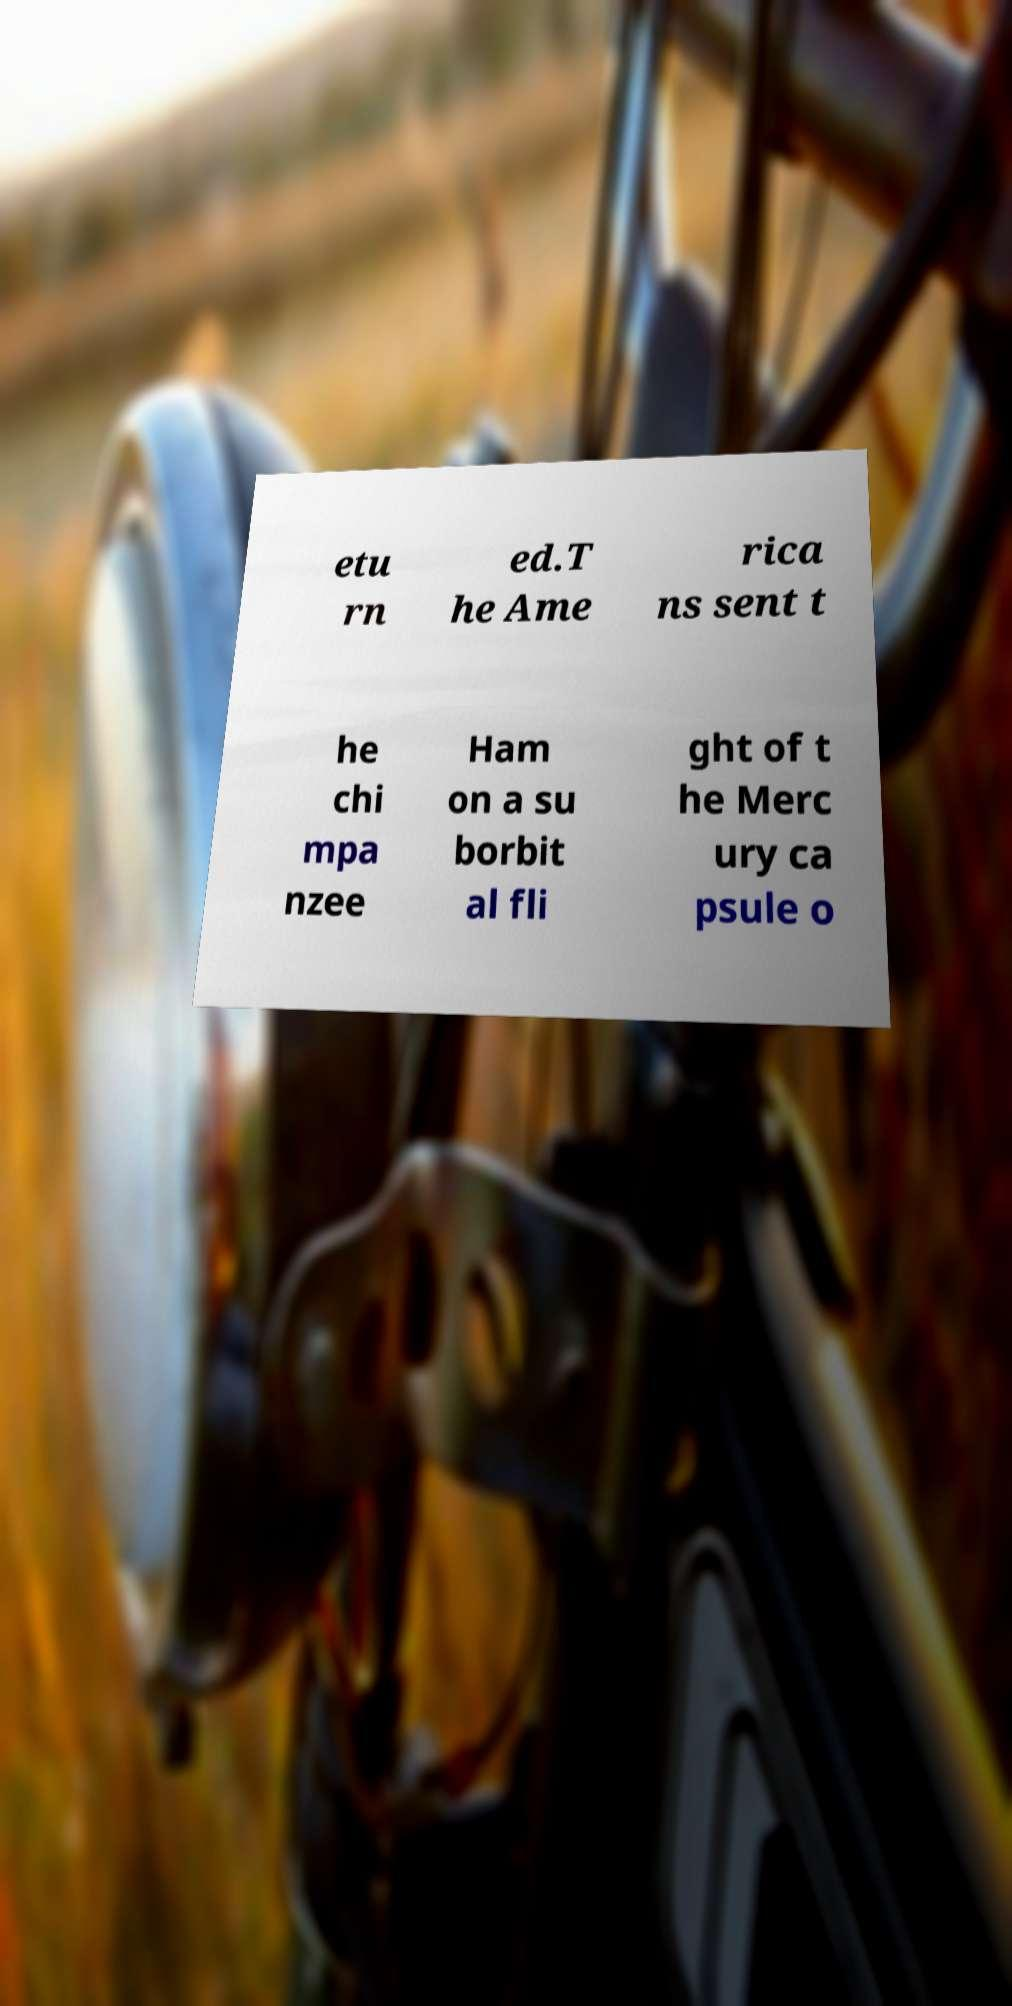I need the written content from this picture converted into text. Can you do that? etu rn ed.T he Ame rica ns sent t he chi mpa nzee Ham on a su borbit al fli ght of t he Merc ury ca psule o 